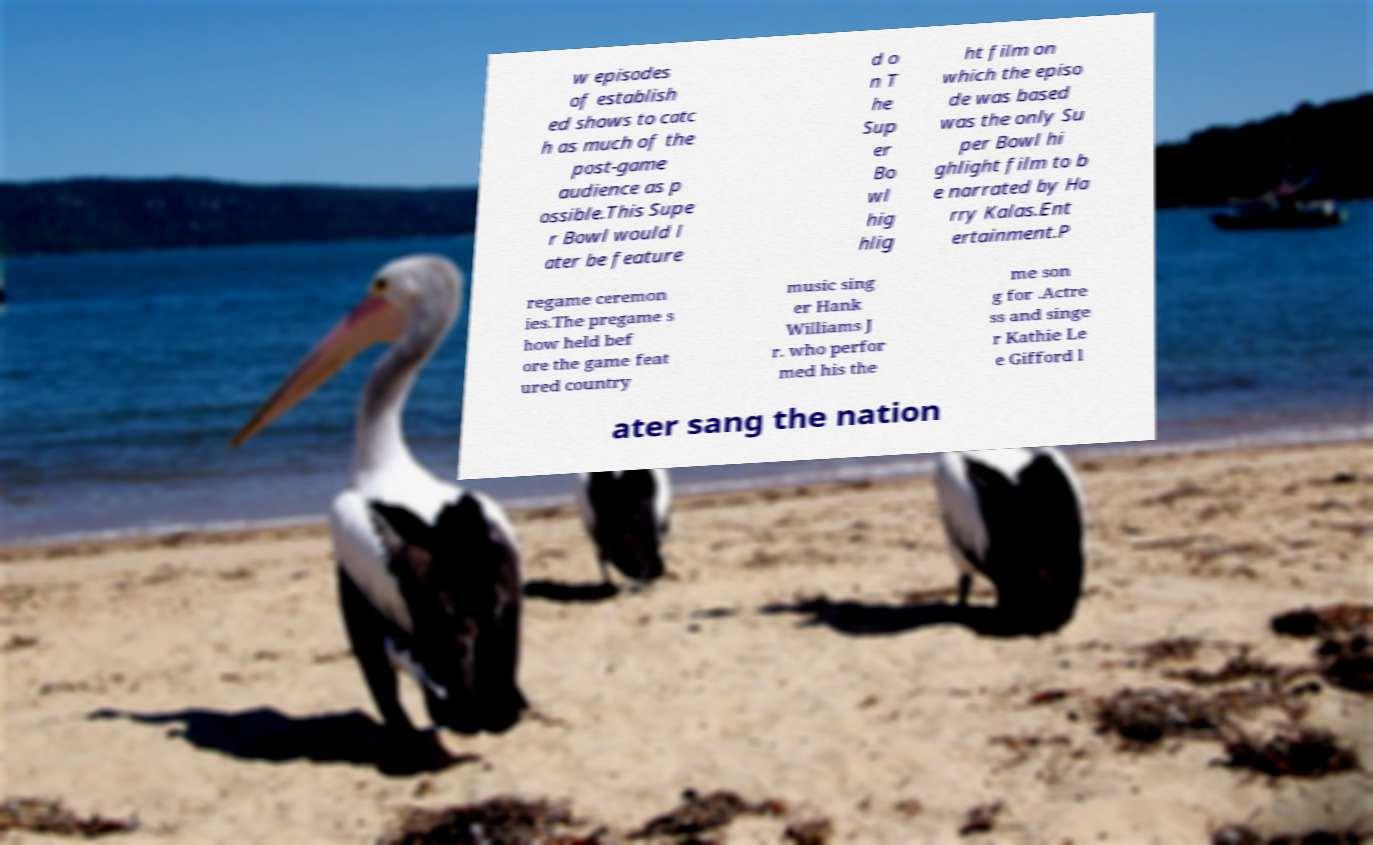Could you extract and type out the text from this image? w episodes of establish ed shows to catc h as much of the post-game audience as p ossible.This Supe r Bowl would l ater be feature d o n T he Sup er Bo wl hig hlig ht film on which the episo de was based was the only Su per Bowl hi ghlight film to b e narrated by Ha rry Kalas.Ent ertainment.P regame ceremon ies.The pregame s how held bef ore the game feat ured country music sing er Hank Williams J r. who perfor med his the me son g for .Actre ss and singe r Kathie Le e Gifford l ater sang the nation 